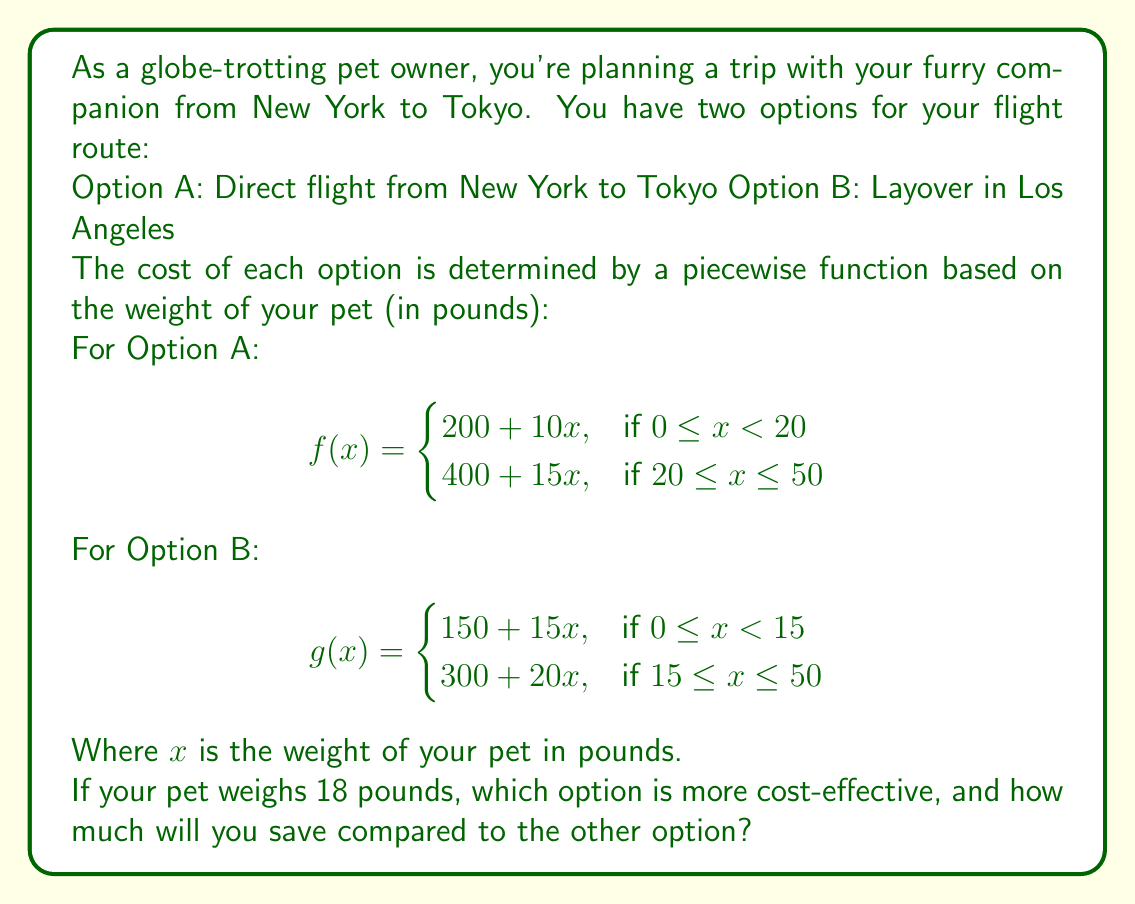Give your solution to this math problem. To solve this problem, we need to calculate the cost for each option given that the pet weighs 18 pounds.

For Option A:
Since $18 < 20$, we use the first piece of the function:
$$f(18) = 200 + 10(18) = 200 + 180 = 380$$

For Option B:
Since $18 \geq 15$, we use the second piece of the function:
$$g(18) = 300 + 20(18) = 300 + 360 = 660$$

Comparing the two costs:
Option A costs $380
Option B costs $660

The difference in cost is:
$$660 - 380 = 280$$

Therefore, Option A (the direct flight) is more cost-effective, and you will save $280 compared to Option B.
Answer: Option A (direct flight) is more cost-effective, saving $280 compared to Option B. 